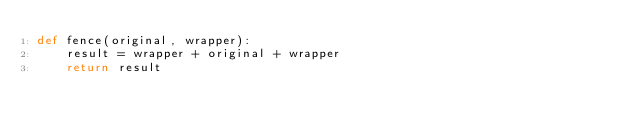Convert code to text. <code><loc_0><loc_0><loc_500><loc_500><_Python_>def fence(original, wrapper):
    result = wrapper + original + wrapper
    return result
</code> 